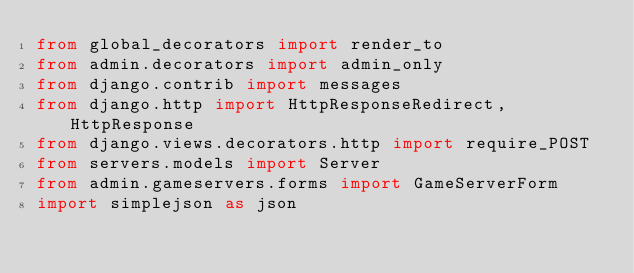<code> <loc_0><loc_0><loc_500><loc_500><_Python_>from global_decorators import render_to
from admin.decorators import admin_only
from django.contrib import messages
from django.http import HttpResponseRedirect, HttpResponse
from django.views.decorators.http import require_POST
from servers.models import Server
from admin.gameservers.forms import GameServerForm
import simplejson as json

</code> 